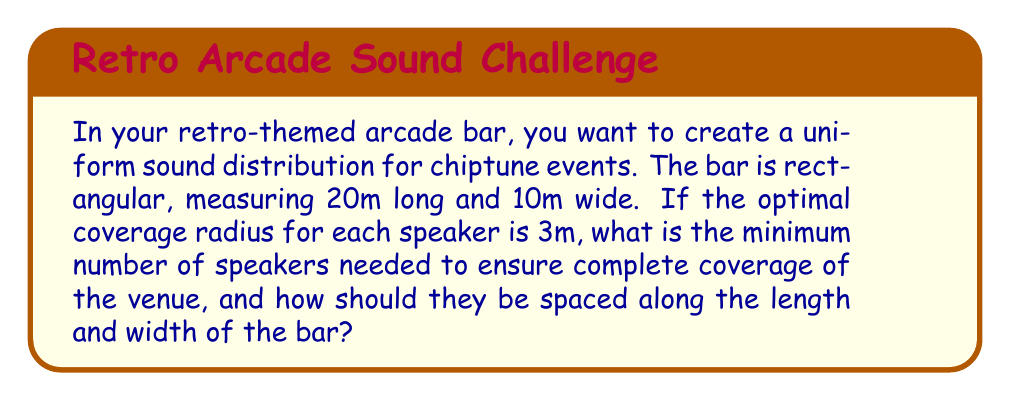Can you answer this question? Let's approach this step-by-step:

1) First, we need to determine the area each speaker can cover. The coverage area of each speaker is a circle with a radius of 3m.
   Area of coverage per speaker = $\pi r^2 = \pi (3m)^2 = 28.27m^2$

2) Now, let's calculate the total area of the bar:
   Area of bar = length × width = 20m × 10m = 200m^2

3) To find the minimum number of speakers needed, we divide the total area by the coverage area per speaker and round up to the nearest whole number:
   Minimum number of speakers = $\lceil \frac{200m^2}{28.27m^2} \rceil = \lceil 7.07 \rceil = 8$ speakers

4) To determine the spacing, we need to distribute these 8 speakers evenly across the bar. Let's assume we place speakers along the length in rows.

5) To minimize the number of rows while ensuring coverage, we can use 3 rows: one along each long wall and one down the center.

6) With 3 rows, we need to distribute 8 speakers among them. The most even distribution would be 3-2-3.

7) For the rows along the walls, the spacing between speakers would be:
   Spacing along length = $\frac{20m}{3} = 6.67m$

8) For the center row with 2 speakers:
   Spacing along length (center) = $\frac{20m}{2} = 10m$

9) The spacing between rows (width) would be:
   Spacing along width = $\frac{10m}{2} = 5m$

This arrangement ensures that no point in the bar is more than 3m from a speaker, providing uniform coverage.

[asy]
size(200,100);
draw((0,0)--(200,0)--(200,100)--(0,100)--cycle);
for(int i=0; i<3; ++i) {
  dot((33.3+i*66.7,0));
  dot((33.3+i*66.7,100));
}
dot((50,50));
dot((150,50));
label("20m",(100,-10));
label("10m",(-10,50),W);
[/asy]
Answer: 8 speakers; Length spacing: 6.67m (walls), 10m (center); Width spacing: 5m 